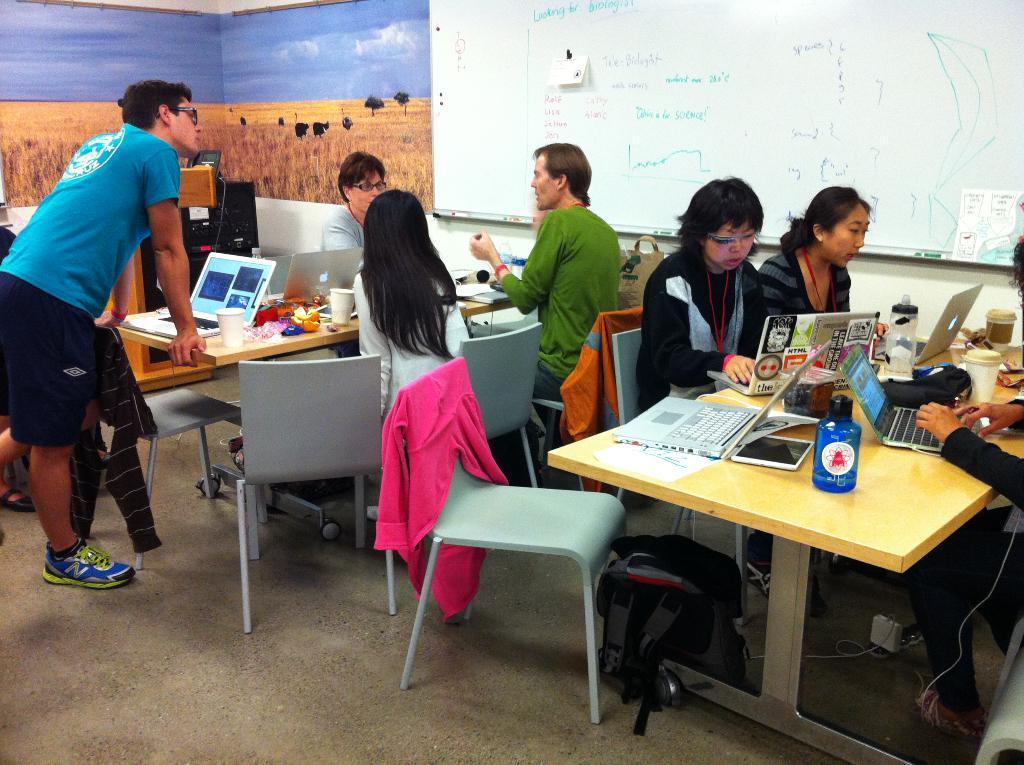How would you summarize this image in a sentence or two? In this image i can see there are group of people who are sitting on a chair and a man is standing on the floor. I can also see there are couple of tables on which there are few objects on it. 